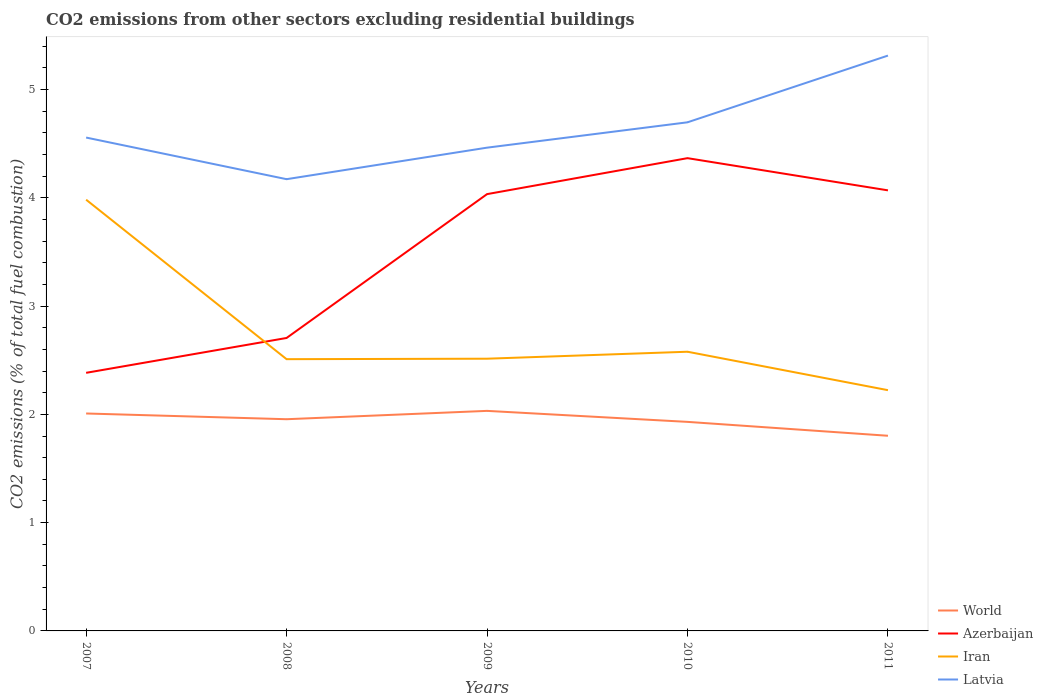Does the line corresponding to Latvia intersect with the line corresponding to Azerbaijan?
Offer a very short reply. No. Is the number of lines equal to the number of legend labels?
Ensure brevity in your answer.  Yes. Across all years, what is the maximum total CO2 emitted in World?
Your answer should be very brief. 1.8. In which year was the total CO2 emitted in Latvia maximum?
Make the answer very short. 2008. What is the total total CO2 emitted in Iran in the graph?
Your response must be concise. -0. What is the difference between the highest and the second highest total CO2 emitted in Iran?
Give a very brief answer. 1.76. What is the difference between two consecutive major ticks on the Y-axis?
Your answer should be very brief. 1. Are the values on the major ticks of Y-axis written in scientific E-notation?
Give a very brief answer. No. Does the graph contain grids?
Offer a terse response. No. Where does the legend appear in the graph?
Offer a terse response. Bottom right. How are the legend labels stacked?
Your response must be concise. Vertical. What is the title of the graph?
Your response must be concise. CO2 emissions from other sectors excluding residential buildings. What is the label or title of the Y-axis?
Your answer should be very brief. CO2 emissions (% of total fuel combustion). What is the CO2 emissions (% of total fuel combustion) of World in 2007?
Give a very brief answer. 2.01. What is the CO2 emissions (% of total fuel combustion) of Azerbaijan in 2007?
Your response must be concise. 2.38. What is the CO2 emissions (% of total fuel combustion) in Iran in 2007?
Your answer should be very brief. 3.98. What is the CO2 emissions (% of total fuel combustion) in Latvia in 2007?
Provide a short and direct response. 4.56. What is the CO2 emissions (% of total fuel combustion) of World in 2008?
Keep it short and to the point. 1.96. What is the CO2 emissions (% of total fuel combustion) of Azerbaijan in 2008?
Offer a very short reply. 2.71. What is the CO2 emissions (% of total fuel combustion) in Iran in 2008?
Your response must be concise. 2.51. What is the CO2 emissions (% of total fuel combustion) in Latvia in 2008?
Offer a very short reply. 4.17. What is the CO2 emissions (% of total fuel combustion) of World in 2009?
Your answer should be very brief. 2.03. What is the CO2 emissions (% of total fuel combustion) in Azerbaijan in 2009?
Offer a very short reply. 4.03. What is the CO2 emissions (% of total fuel combustion) of Iran in 2009?
Make the answer very short. 2.51. What is the CO2 emissions (% of total fuel combustion) of Latvia in 2009?
Your answer should be compact. 4.46. What is the CO2 emissions (% of total fuel combustion) of World in 2010?
Ensure brevity in your answer.  1.93. What is the CO2 emissions (% of total fuel combustion) in Azerbaijan in 2010?
Offer a terse response. 4.37. What is the CO2 emissions (% of total fuel combustion) in Iran in 2010?
Make the answer very short. 2.58. What is the CO2 emissions (% of total fuel combustion) in Latvia in 2010?
Ensure brevity in your answer.  4.7. What is the CO2 emissions (% of total fuel combustion) in World in 2011?
Provide a succinct answer. 1.8. What is the CO2 emissions (% of total fuel combustion) of Azerbaijan in 2011?
Provide a succinct answer. 4.07. What is the CO2 emissions (% of total fuel combustion) in Iran in 2011?
Ensure brevity in your answer.  2.22. What is the CO2 emissions (% of total fuel combustion) of Latvia in 2011?
Give a very brief answer. 5.31. Across all years, what is the maximum CO2 emissions (% of total fuel combustion) in World?
Give a very brief answer. 2.03. Across all years, what is the maximum CO2 emissions (% of total fuel combustion) in Azerbaijan?
Keep it short and to the point. 4.37. Across all years, what is the maximum CO2 emissions (% of total fuel combustion) in Iran?
Make the answer very short. 3.98. Across all years, what is the maximum CO2 emissions (% of total fuel combustion) of Latvia?
Ensure brevity in your answer.  5.31. Across all years, what is the minimum CO2 emissions (% of total fuel combustion) of World?
Offer a very short reply. 1.8. Across all years, what is the minimum CO2 emissions (% of total fuel combustion) in Azerbaijan?
Offer a terse response. 2.38. Across all years, what is the minimum CO2 emissions (% of total fuel combustion) of Iran?
Give a very brief answer. 2.22. Across all years, what is the minimum CO2 emissions (% of total fuel combustion) in Latvia?
Your answer should be very brief. 4.17. What is the total CO2 emissions (% of total fuel combustion) of World in the graph?
Provide a succinct answer. 9.73. What is the total CO2 emissions (% of total fuel combustion) in Azerbaijan in the graph?
Provide a succinct answer. 17.56. What is the total CO2 emissions (% of total fuel combustion) of Iran in the graph?
Keep it short and to the point. 13.81. What is the total CO2 emissions (% of total fuel combustion) of Latvia in the graph?
Your answer should be compact. 23.2. What is the difference between the CO2 emissions (% of total fuel combustion) in World in 2007 and that in 2008?
Make the answer very short. 0.05. What is the difference between the CO2 emissions (% of total fuel combustion) of Azerbaijan in 2007 and that in 2008?
Give a very brief answer. -0.32. What is the difference between the CO2 emissions (% of total fuel combustion) in Iran in 2007 and that in 2008?
Your answer should be very brief. 1.47. What is the difference between the CO2 emissions (% of total fuel combustion) in Latvia in 2007 and that in 2008?
Offer a terse response. 0.38. What is the difference between the CO2 emissions (% of total fuel combustion) of World in 2007 and that in 2009?
Give a very brief answer. -0.02. What is the difference between the CO2 emissions (% of total fuel combustion) in Azerbaijan in 2007 and that in 2009?
Provide a succinct answer. -1.65. What is the difference between the CO2 emissions (% of total fuel combustion) of Iran in 2007 and that in 2009?
Ensure brevity in your answer.  1.47. What is the difference between the CO2 emissions (% of total fuel combustion) in Latvia in 2007 and that in 2009?
Your response must be concise. 0.09. What is the difference between the CO2 emissions (% of total fuel combustion) in World in 2007 and that in 2010?
Your answer should be compact. 0.08. What is the difference between the CO2 emissions (% of total fuel combustion) in Azerbaijan in 2007 and that in 2010?
Ensure brevity in your answer.  -1.98. What is the difference between the CO2 emissions (% of total fuel combustion) in Iran in 2007 and that in 2010?
Offer a terse response. 1.4. What is the difference between the CO2 emissions (% of total fuel combustion) in Latvia in 2007 and that in 2010?
Make the answer very short. -0.14. What is the difference between the CO2 emissions (% of total fuel combustion) in World in 2007 and that in 2011?
Provide a succinct answer. 0.21. What is the difference between the CO2 emissions (% of total fuel combustion) in Azerbaijan in 2007 and that in 2011?
Ensure brevity in your answer.  -1.69. What is the difference between the CO2 emissions (% of total fuel combustion) of Iran in 2007 and that in 2011?
Keep it short and to the point. 1.76. What is the difference between the CO2 emissions (% of total fuel combustion) in Latvia in 2007 and that in 2011?
Your answer should be compact. -0.76. What is the difference between the CO2 emissions (% of total fuel combustion) of World in 2008 and that in 2009?
Your response must be concise. -0.08. What is the difference between the CO2 emissions (% of total fuel combustion) in Azerbaijan in 2008 and that in 2009?
Keep it short and to the point. -1.33. What is the difference between the CO2 emissions (% of total fuel combustion) of Iran in 2008 and that in 2009?
Provide a short and direct response. -0. What is the difference between the CO2 emissions (% of total fuel combustion) in Latvia in 2008 and that in 2009?
Provide a short and direct response. -0.29. What is the difference between the CO2 emissions (% of total fuel combustion) in World in 2008 and that in 2010?
Offer a very short reply. 0.02. What is the difference between the CO2 emissions (% of total fuel combustion) of Azerbaijan in 2008 and that in 2010?
Your answer should be very brief. -1.66. What is the difference between the CO2 emissions (% of total fuel combustion) in Iran in 2008 and that in 2010?
Your response must be concise. -0.07. What is the difference between the CO2 emissions (% of total fuel combustion) in Latvia in 2008 and that in 2010?
Your answer should be very brief. -0.53. What is the difference between the CO2 emissions (% of total fuel combustion) of World in 2008 and that in 2011?
Your response must be concise. 0.15. What is the difference between the CO2 emissions (% of total fuel combustion) of Azerbaijan in 2008 and that in 2011?
Provide a succinct answer. -1.36. What is the difference between the CO2 emissions (% of total fuel combustion) of Iran in 2008 and that in 2011?
Provide a short and direct response. 0.29. What is the difference between the CO2 emissions (% of total fuel combustion) of Latvia in 2008 and that in 2011?
Keep it short and to the point. -1.14. What is the difference between the CO2 emissions (% of total fuel combustion) in World in 2009 and that in 2010?
Your response must be concise. 0.1. What is the difference between the CO2 emissions (% of total fuel combustion) in Azerbaijan in 2009 and that in 2010?
Your answer should be compact. -0.33. What is the difference between the CO2 emissions (% of total fuel combustion) of Iran in 2009 and that in 2010?
Your answer should be compact. -0.06. What is the difference between the CO2 emissions (% of total fuel combustion) of Latvia in 2009 and that in 2010?
Keep it short and to the point. -0.23. What is the difference between the CO2 emissions (% of total fuel combustion) in World in 2009 and that in 2011?
Provide a succinct answer. 0.23. What is the difference between the CO2 emissions (% of total fuel combustion) of Azerbaijan in 2009 and that in 2011?
Keep it short and to the point. -0.03. What is the difference between the CO2 emissions (% of total fuel combustion) in Iran in 2009 and that in 2011?
Your answer should be very brief. 0.29. What is the difference between the CO2 emissions (% of total fuel combustion) in Latvia in 2009 and that in 2011?
Your response must be concise. -0.85. What is the difference between the CO2 emissions (% of total fuel combustion) of World in 2010 and that in 2011?
Offer a terse response. 0.13. What is the difference between the CO2 emissions (% of total fuel combustion) of Azerbaijan in 2010 and that in 2011?
Keep it short and to the point. 0.3. What is the difference between the CO2 emissions (% of total fuel combustion) of Iran in 2010 and that in 2011?
Your answer should be compact. 0.35. What is the difference between the CO2 emissions (% of total fuel combustion) in Latvia in 2010 and that in 2011?
Give a very brief answer. -0.62. What is the difference between the CO2 emissions (% of total fuel combustion) in World in 2007 and the CO2 emissions (% of total fuel combustion) in Azerbaijan in 2008?
Your response must be concise. -0.7. What is the difference between the CO2 emissions (% of total fuel combustion) of World in 2007 and the CO2 emissions (% of total fuel combustion) of Iran in 2008?
Ensure brevity in your answer.  -0.5. What is the difference between the CO2 emissions (% of total fuel combustion) of World in 2007 and the CO2 emissions (% of total fuel combustion) of Latvia in 2008?
Your response must be concise. -2.16. What is the difference between the CO2 emissions (% of total fuel combustion) in Azerbaijan in 2007 and the CO2 emissions (% of total fuel combustion) in Iran in 2008?
Offer a terse response. -0.13. What is the difference between the CO2 emissions (% of total fuel combustion) in Azerbaijan in 2007 and the CO2 emissions (% of total fuel combustion) in Latvia in 2008?
Your response must be concise. -1.79. What is the difference between the CO2 emissions (% of total fuel combustion) of Iran in 2007 and the CO2 emissions (% of total fuel combustion) of Latvia in 2008?
Ensure brevity in your answer.  -0.19. What is the difference between the CO2 emissions (% of total fuel combustion) in World in 2007 and the CO2 emissions (% of total fuel combustion) in Azerbaijan in 2009?
Your answer should be very brief. -2.03. What is the difference between the CO2 emissions (% of total fuel combustion) of World in 2007 and the CO2 emissions (% of total fuel combustion) of Iran in 2009?
Your response must be concise. -0.51. What is the difference between the CO2 emissions (% of total fuel combustion) of World in 2007 and the CO2 emissions (% of total fuel combustion) of Latvia in 2009?
Your answer should be compact. -2.45. What is the difference between the CO2 emissions (% of total fuel combustion) of Azerbaijan in 2007 and the CO2 emissions (% of total fuel combustion) of Iran in 2009?
Offer a very short reply. -0.13. What is the difference between the CO2 emissions (% of total fuel combustion) in Azerbaijan in 2007 and the CO2 emissions (% of total fuel combustion) in Latvia in 2009?
Keep it short and to the point. -2.08. What is the difference between the CO2 emissions (% of total fuel combustion) of Iran in 2007 and the CO2 emissions (% of total fuel combustion) of Latvia in 2009?
Ensure brevity in your answer.  -0.48. What is the difference between the CO2 emissions (% of total fuel combustion) in World in 2007 and the CO2 emissions (% of total fuel combustion) in Azerbaijan in 2010?
Make the answer very short. -2.36. What is the difference between the CO2 emissions (% of total fuel combustion) in World in 2007 and the CO2 emissions (% of total fuel combustion) in Iran in 2010?
Make the answer very short. -0.57. What is the difference between the CO2 emissions (% of total fuel combustion) of World in 2007 and the CO2 emissions (% of total fuel combustion) of Latvia in 2010?
Give a very brief answer. -2.69. What is the difference between the CO2 emissions (% of total fuel combustion) in Azerbaijan in 2007 and the CO2 emissions (% of total fuel combustion) in Iran in 2010?
Your answer should be compact. -0.19. What is the difference between the CO2 emissions (% of total fuel combustion) of Azerbaijan in 2007 and the CO2 emissions (% of total fuel combustion) of Latvia in 2010?
Your answer should be very brief. -2.31. What is the difference between the CO2 emissions (% of total fuel combustion) of Iran in 2007 and the CO2 emissions (% of total fuel combustion) of Latvia in 2010?
Keep it short and to the point. -0.71. What is the difference between the CO2 emissions (% of total fuel combustion) of World in 2007 and the CO2 emissions (% of total fuel combustion) of Azerbaijan in 2011?
Offer a very short reply. -2.06. What is the difference between the CO2 emissions (% of total fuel combustion) of World in 2007 and the CO2 emissions (% of total fuel combustion) of Iran in 2011?
Provide a succinct answer. -0.22. What is the difference between the CO2 emissions (% of total fuel combustion) of World in 2007 and the CO2 emissions (% of total fuel combustion) of Latvia in 2011?
Make the answer very short. -3.31. What is the difference between the CO2 emissions (% of total fuel combustion) of Azerbaijan in 2007 and the CO2 emissions (% of total fuel combustion) of Iran in 2011?
Ensure brevity in your answer.  0.16. What is the difference between the CO2 emissions (% of total fuel combustion) of Azerbaijan in 2007 and the CO2 emissions (% of total fuel combustion) of Latvia in 2011?
Your answer should be very brief. -2.93. What is the difference between the CO2 emissions (% of total fuel combustion) in Iran in 2007 and the CO2 emissions (% of total fuel combustion) in Latvia in 2011?
Give a very brief answer. -1.33. What is the difference between the CO2 emissions (% of total fuel combustion) in World in 2008 and the CO2 emissions (% of total fuel combustion) in Azerbaijan in 2009?
Ensure brevity in your answer.  -2.08. What is the difference between the CO2 emissions (% of total fuel combustion) in World in 2008 and the CO2 emissions (% of total fuel combustion) in Iran in 2009?
Provide a short and direct response. -0.56. What is the difference between the CO2 emissions (% of total fuel combustion) in World in 2008 and the CO2 emissions (% of total fuel combustion) in Latvia in 2009?
Offer a very short reply. -2.51. What is the difference between the CO2 emissions (% of total fuel combustion) in Azerbaijan in 2008 and the CO2 emissions (% of total fuel combustion) in Iran in 2009?
Offer a very short reply. 0.19. What is the difference between the CO2 emissions (% of total fuel combustion) in Azerbaijan in 2008 and the CO2 emissions (% of total fuel combustion) in Latvia in 2009?
Ensure brevity in your answer.  -1.76. What is the difference between the CO2 emissions (% of total fuel combustion) of Iran in 2008 and the CO2 emissions (% of total fuel combustion) of Latvia in 2009?
Make the answer very short. -1.95. What is the difference between the CO2 emissions (% of total fuel combustion) of World in 2008 and the CO2 emissions (% of total fuel combustion) of Azerbaijan in 2010?
Offer a terse response. -2.41. What is the difference between the CO2 emissions (% of total fuel combustion) of World in 2008 and the CO2 emissions (% of total fuel combustion) of Iran in 2010?
Make the answer very short. -0.62. What is the difference between the CO2 emissions (% of total fuel combustion) of World in 2008 and the CO2 emissions (% of total fuel combustion) of Latvia in 2010?
Keep it short and to the point. -2.74. What is the difference between the CO2 emissions (% of total fuel combustion) of Azerbaijan in 2008 and the CO2 emissions (% of total fuel combustion) of Iran in 2010?
Your response must be concise. 0.13. What is the difference between the CO2 emissions (% of total fuel combustion) in Azerbaijan in 2008 and the CO2 emissions (% of total fuel combustion) in Latvia in 2010?
Provide a short and direct response. -1.99. What is the difference between the CO2 emissions (% of total fuel combustion) in Iran in 2008 and the CO2 emissions (% of total fuel combustion) in Latvia in 2010?
Offer a very short reply. -2.19. What is the difference between the CO2 emissions (% of total fuel combustion) of World in 2008 and the CO2 emissions (% of total fuel combustion) of Azerbaijan in 2011?
Your answer should be very brief. -2.11. What is the difference between the CO2 emissions (% of total fuel combustion) in World in 2008 and the CO2 emissions (% of total fuel combustion) in Iran in 2011?
Keep it short and to the point. -0.27. What is the difference between the CO2 emissions (% of total fuel combustion) in World in 2008 and the CO2 emissions (% of total fuel combustion) in Latvia in 2011?
Provide a succinct answer. -3.36. What is the difference between the CO2 emissions (% of total fuel combustion) of Azerbaijan in 2008 and the CO2 emissions (% of total fuel combustion) of Iran in 2011?
Make the answer very short. 0.48. What is the difference between the CO2 emissions (% of total fuel combustion) in Azerbaijan in 2008 and the CO2 emissions (% of total fuel combustion) in Latvia in 2011?
Provide a short and direct response. -2.61. What is the difference between the CO2 emissions (% of total fuel combustion) of Iran in 2008 and the CO2 emissions (% of total fuel combustion) of Latvia in 2011?
Provide a succinct answer. -2.8. What is the difference between the CO2 emissions (% of total fuel combustion) in World in 2009 and the CO2 emissions (% of total fuel combustion) in Azerbaijan in 2010?
Ensure brevity in your answer.  -2.33. What is the difference between the CO2 emissions (% of total fuel combustion) of World in 2009 and the CO2 emissions (% of total fuel combustion) of Iran in 2010?
Keep it short and to the point. -0.55. What is the difference between the CO2 emissions (% of total fuel combustion) of World in 2009 and the CO2 emissions (% of total fuel combustion) of Latvia in 2010?
Give a very brief answer. -2.67. What is the difference between the CO2 emissions (% of total fuel combustion) of Azerbaijan in 2009 and the CO2 emissions (% of total fuel combustion) of Iran in 2010?
Provide a succinct answer. 1.46. What is the difference between the CO2 emissions (% of total fuel combustion) of Azerbaijan in 2009 and the CO2 emissions (% of total fuel combustion) of Latvia in 2010?
Your answer should be very brief. -0.66. What is the difference between the CO2 emissions (% of total fuel combustion) in Iran in 2009 and the CO2 emissions (% of total fuel combustion) in Latvia in 2010?
Give a very brief answer. -2.18. What is the difference between the CO2 emissions (% of total fuel combustion) of World in 2009 and the CO2 emissions (% of total fuel combustion) of Azerbaijan in 2011?
Keep it short and to the point. -2.04. What is the difference between the CO2 emissions (% of total fuel combustion) in World in 2009 and the CO2 emissions (% of total fuel combustion) in Iran in 2011?
Provide a short and direct response. -0.19. What is the difference between the CO2 emissions (% of total fuel combustion) in World in 2009 and the CO2 emissions (% of total fuel combustion) in Latvia in 2011?
Offer a very short reply. -3.28. What is the difference between the CO2 emissions (% of total fuel combustion) in Azerbaijan in 2009 and the CO2 emissions (% of total fuel combustion) in Iran in 2011?
Make the answer very short. 1.81. What is the difference between the CO2 emissions (% of total fuel combustion) of Azerbaijan in 2009 and the CO2 emissions (% of total fuel combustion) of Latvia in 2011?
Ensure brevity in your answer.  -1.28. What is the difference between the CO2 emissions (% of total fuel combustion) in Iran in 2009 and the CO2 emissions (% of total fuel combustion) in Latvia in 2011?
Make the answer very short. -2.8. What is the difference between the CO2 emissions (% of total fuel combustion) in World in 2010 and the CO2 emissions (% of total fuel combustion) in Azerbaijan in 2011?
Provide a short and direct response. -2.14. What is the difference between the CO2 emissions (% of total fuel combustion) in World in 2010 and the CO2 emissions (% of total fuel combustion) in Iran in 2011?
Your answer should be very brief. -0.29. What is the difference between the CO2 emissions (% of total fuel combustion) in World in 2010 and the CO2 emissions (% of total fuel combustion) in Latvia in 2011?
Offer a very short reply. -3.38. What is the difference between the CO2 emissions (% of total fuel combustion) of Azerbaijan in 2010 and the CO2 emissions (% of total fuel combustion) of Iran in 2011?
Your answer should be very brief. 2.14. What is the difference between the CO2 emissions (% of total fuel combustion) of Azerbaijan in 2010 and the CO2 emissions (% of total fuel combustion) of Latvia in 2011?
Ensure brevity in your answer.  -0.95. What is the difference between the CO2 emissions (% of total fuel combustion) in Iran in 2010 and the CO2 emissions (% of total fuel combustion) in Latvia in 2011?
Give a very brief answer. -2.73. What is the average CO2 emissions (% of total fuel combustion) in World per year?
Provide a short and direct response. 1.95. What is the average CO2 emissions (% of total fuel combustion) in Azerbaijan per year?
Make the answer very short. 3.51. What is the average CO2 emissions (% of total fuel combustion) of Iran per year?
Make the answer very short. 2.76. What is the average CO2 emissions (% of total fuel combustion) of Latvia per year?
Provide a short and direct response. 4.64. In the year 2007, what is the difference between the CO2 emissions (% of total fuel combustion) of World and CO2 emissions (% of total fuel combustion) of Azerbaijan?
Your answer should be very brief. -0.38. In the year 2007, what is the difference between the CO2 emissions (% of total fuel combustion) of World and CO2 emissions (% of total fuel combustion) of Iran?
Provide a succinct answer. -1.97. In the year 2007, what is the difference between the CO2 emissions (% of total fuel combustion) in World and CO2 emissions (% of total fuel combustion) in Latvia?
Make the answer very short. -2.55. In the year 2007, what is the difference between the CO2 emissions (% of total fuel combustion) of Azerbaijan and CO2 emissions (% of total fuel combustion) of Iran?
Your response must be concise. -1.6. In the year 2007, what is the difference between the CO2 emissions (% of total fuel combustion) in Azerbaijan and CO2 emissions (% of total fuel combustion) in Latvia?
Keep it short and to the point. -2.17. In the year 2007, what is the difference between the CO2 emissions (% of total fuel combustion) of Iran and CO2 emissions (% of total fuel combustion) of Latvia?
Keep it short and to the point. -0.57. In the year 2008, what is the difference between the CO2 emissions (% of total fuel combustion) in World and CO2 emissions (% of total fuel combustion) in Azerbaijan?
Keep it short and to the point. -0.75. In the year 2008, what is the difference between the CO2 emissions (% of total fuel combustion) of World and CO2 emissions (% of total fuel combustion) of Iran?
Your response must be concise. -0.55. In the year 2008, what is the difference between the CO2 emissions (% of total fuel combustion) of World and CO2 emissions (% of total fuel combustion) of Latvia?
Your response must be concise. -2.22. In the year 2008, what is the difference between the CO2 emissions (% of total fuel combustion) in Azerbaijan and CO2 emissions (% of total fuel combustion) in Iran?
Your answer should be very brief. 0.2. In the year 2008, what is the difference between the CO2 emissions (% of total fuel combustion) in Azerbaijan and CO2 emissions (% of total fuel combustion) in Latvia?
Your answer should be very brief. -1.47. In the year 2008, what is the difference between the CO2 emissions (% of total fuel combustion) in Iran and CO2 emissions (% of total fuel combustion) in Latvia?
Make the answer very short. -1.66. In the year 2009, what is the difference between the CO2 emissions (% of total fuel combustion) in World and CO2 emissions (% of total fuel combustion) in Azerbaijan?
Keep it short and to the point. -2. In the year 2009, what is the difference between the CO2 emissions (% of total fuel combustion) of World and CO2 emissions (% of total fuel combustion) of Iran?
Make the answer very short. -0.48. In the year 2009, what is the difference between the CO2 emissions (% of total fuel combustion) in World and CO2 emissions (% of total fuel combustion) in Latvia?
Offer a terse response. -2.43. In the year 2009, what is the difference between the CO2 emissions (% of total fuel combustion) of Azerbaijan and CO2 emissions (% of total fuel combustion) of Iran?
Offer a very short reply. 1.52. In the year 2009, what is the difference between the CO2 emissions (% of total fuel combustion) of Azerbaijan and CO2 emissions (% of total fuel combustion) of Latvia?
Ensure brevity in your answer.  -0.43. In the year 2009, what is the difference between the CO2 emissions (% of total fuel combustion) in Iran and CO2 emissions (% of total fuel combustion) in Latvia?
Your response must be concise. -1.95. In the year 2010, what is the difference between the CO2 emissions (% of total fuel combustion) of World and CO2 emissions (% of total fuel combustion) of Azerbaijan?
Provide a succinct answer. -2.44. In the year 2010, what is the difference between the CO2 emissions (% of total fuel combustion) in World and CO2 emissions (% of total fuel combustion) in Iran?
Offer a very short reply. -0.65. In the year 2010, what is the difference between the CO2 emissions (% of total fuel combustion) in World and CO2 emissions (% of total fuel combustion) in Latvia?
Your response must be concise. -2.77. In the year 2010, what is the difference between the CO2 emissions (% of total fuel combustion) of Azerbaijan and CO2 emissions (% of total fuel combustion) of Iran?
Make the answer very short. 1.79. In the year 2010, what is the difference between the CO2 emissions (% of total fuel combustion) of Azerbaijan and CO2 emissions (% of total fuel combustion) of Latvia?
Give a very brief answer. -0.33. In the year 2010, what is the difference between the CO2 emissions (% of total fuel combustion) of Iran and CO2 emissions (% of total fuel combustion) of Latvia?
Offer a very short reply. -2.12. In the year 2011, what is the difference between the CO2 emissions (% of total fuel combustion) of World and CO2 emissions (% of total fuel combustion) of Azerbaijan?
Ensure brevity in your answer.  -2.27. In the year 2011, what is the difference between the CO2 emissions (% of total fuel combustion) in World and CO2 emissions (% of total fuel combustion) in Iran?
Offer a very short reply. -0.42. In the year 2011, what is the difference between the CO2 emissions (% of total fuel combustion) in World and CO2 emissions (% of total fuel combustion) in Latvia?
Your answer should be compact. -3.51. In the year 2011, what is the difference between the CO2 emissions (% of total fuel combustion) of Azerbaijan and CO2 emissions (% of total fuel combustion) of Iran?
Keep it short and to the point. 1.85. In the year 2011, what is the difference between the CO2 emissions (% of total fuel combustion) of Azerbaijan and CO2 emissions (% of total fuel combustion) of Latvia?
Your response must be concise. -1.24. In the year 2011, what is the difference between the CO2 emissions (% of total fuel combustion) in Iran and CO2 emissions (% of total fuel combustion) in Latvia?
Your response must be concise. -3.09. What is the ratio of the CO2 emissions (% of total fuel combustion) of World in 2007 to that in 2008?
Keep it short and to the point. 1.03. What is the ratio of the CO2 emissions (% of total fuel combustion) in Azerbaijan in 2007 to that in 2008?
Provide a short and direct response. 0.88. What is the ratio of the CO2 emissions (% of total fuel combustion) in Iran in 2007 to that in 2008?
Your answer should be very brief. 1.59. What is the ratio of the CO2 emissions (% of total fuel combustion) in Latvia in 2007 to that in 2008?
Provide a succinct answer. 1.09. What is the ratio of the CO2 emissions (% of total fuel combustion) in World in 2007 to that in 2009?
Offer a very short reply. 0.99. What is the ratio of the CO2 emissions (% of total fuel combustion) of Azerbaijan in 2007 to that in 2009?
Give a very brief answer. 0.59. What is the ratio of the CO2 emissions (% of total fuel combustion) of Iran in 2007 to that in 2009?
Ensure brevity in your answer.  1.58. What is the ratio of the CO2 emissions (% of total fuel combustion) in Latvia in 2007 to that in 2009?
Make the answer very short. 1.02. What is the ratio of the CO2 emissions (% of total fuel combustion) in World in 2007 to that in 2010?
Your answer should be compact. 1.04. What is the ratio of the CO2 emissions (% of total fuel combustion) of Azerbaijan in 2007 to that in 2010?
Your response must be concise. 0.55. What is the ratio of the CO2 emissions (% of total fuel combustion) of Iran in 2007 to that in 2010?
Ensure brevity in your answer.  1.54. What is the ratio of the CO2 emissions (% of total fuel combustion) of World in 2007 to that in 2011?
Keep it short and to the point. 1.11. What is the ratio of the CO2 emissions (% of total fuel combustion) in Azerbaijan in 2007 to that in 2011?
Ensure brevity in your answer.  0.59. What is the ratio of the CO2 emissions (% of total fuel combustion) of Iran in 2007 to that in 2011?
Give a very brief answer. 1.79. What is the ratio of the CO2 emissions (% of total fuel combustion) in Latvia in 2007 to that in 2011?
Provide a succinct answer. 0.86. What is the ratio of the CO2 emissions (% of total fuel combustion) of World in 2008 to that in 2009?
Provide a short and direct response. 0.96. What is the ratio of the CO2 emissions (% of total fuel combustion) in Azerbaijan in 2008 to that in 2009?
Your answer should be very brief. 0.67. What is the ratio of the CO2 emissions (% of total fuel combustion) of Iran in 2008 to that in 2009?
Make the answer very short. 1. What is the ratio of the CO2 emissions (% of total fuel combustion) in Latvia in 2008 to that in 2009?
Provide a short and direct response. 0.93. What is the ratio of the CO2 emissions (% of total fuel combustion) in World in 2008 to that in 2010?
Offer a terse response. 1.01. What is the ratio of the CO2 emissions (% of total fuel combustion) of Azerbaijan in 2008 to that in 2010?
Give a very brief answer. 0.62. What is the ratio of the CO2 emissions (% of total fuel combustion) in Iran in 2008 to that in 2010?
Offer a terse response. 0.97. What is the ratio of the CO2 emissions (% of total fuel combustion) of Latvia in 2008 to that in 2010?
Your answer should be compact. 0.89. What is the ratio of the CO2 emissions (% of total fuel combustion) in World in 2008 to that in 2011?
Provide a succinct answer. 1.08. What is the ratio of the CO2 emissions (% of total fuel combustion) in Azerbaijan in 2008 to that in 2011?
Keep it short and to the point. 0.67. What is the ratio of the CO2 emissions (% of total fuel combustion) in Iran in 2008 to that in 2011?
Your answer should be compact. 1.13. What is the ratio of the CO2 emissions (% of total fuel combustion) of Latvia in 2008 to that in 2011?
Make the answer very short. 0.79. What is the ratio of the CO2 emissions (% of total fuel combustion) in World in 2009 to that in 2010?
Offer a terse response. 1.05. What is the ratio of the CO2 emissions (% of total fuel combustion) of Azerbaijan in 2009 to that in 2010?
Provide a short and direct response. 0.92. What is the ratio of the CO2 emissions (% of total fuel combustion) in Iran in 2009 to that in 2010?
Give a very brief answer. 0.98. What is the ratio of the CO2 emissions (% of total fuel combustion) of Latvia in 2009 to that in 2010?
Your answer should be very brief. 0.95. What is the ratio of the CO2 emissions (% of total fuel combustion) of World in 2009 to that in 2011?
Keep it short and to the point. 1.13. What is the ratio of the CO2 emissions (% of total fuel combustion) in Iran in 2009 to that in 2011?
Ensure brevity in your answer.  1.13. What is the ratio of the CO2 emissions (% of total fuel combustion) in Latvia in 2009 to that in 2011?
Offer a terse response. 0.84. What is the ratio of the CO2 emissions (% of total fuel combustion) of World in 2010 to that in 2011?
Your response must be concise. 1.07. What is the ratio of the CO2 emissions (% of total fuel combustion) of Azerbaijan in 2010 to that in 2011?
Offer a terse response. 1.07. What is the ratio of the CO2 emissions (% of total fuel combustion) in Iran in 2010 to that in 2011?
Offer a very short reply. 1.16. What is the ratio of the CO2 emissions (% of total fuel combustion) of Latvia in 2010 to that in 2011?
Give a very brief answer. 0.88. What is the difference between the highest and the second highest CO2 emissions (% of total fuel combustion) in World?
Keep it short and to the point. 0.02. What is the difference between the highest and the second highest CO2 emissions (% of total fuel combustion) of Azerbaijan?
Provide a short and direct response. 0.3. What is the difference between the highest and the second highest CO2 emissions (% of total fuel combustion) in Iran?
Offer a terse response. 1.4. What is the difference between the highest and the second highest CO2 emissions (% of total fuel combustion) in Latvia?
Offer a very short reply. 0.62. What is the difference between the highest and the lowest CO2 emissions (% of total fuel combustion) in World?
Offer a very short reply. 0.23. What is the difference between the highest and the lowest CO2 emissions (% of total fuel combustion) of Azerbaijan?
Give a very brief answer. 1.98. What is the difference between the highest and the lowest CO2 emissions (% of total fuel combustion) of Iran?
Your answer should be compact. 1.76. What is the difference between the highest and the lowest CO2 emissions (% of total fuel combustion) in Latvia?
Give a very brief answer. 1.14. 